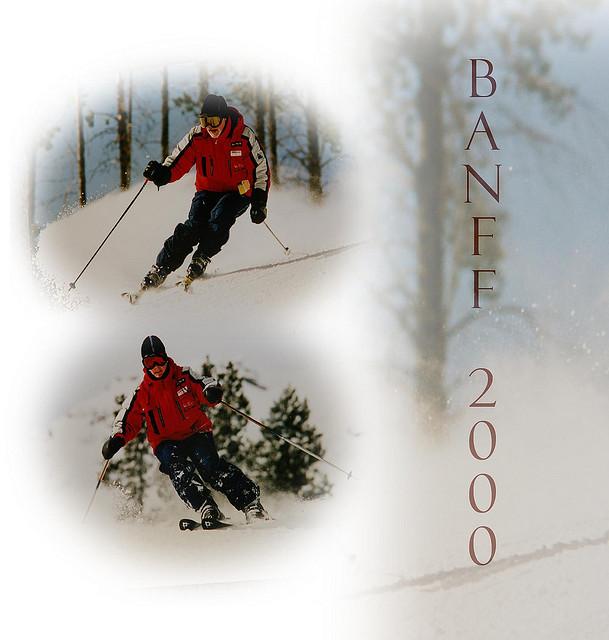Are they both wearing goggles?
Be succinct. Yes. Is this a calendar page?
Be succinct. Yes. What year does the picture say it is?
Be succinct. 2000. 